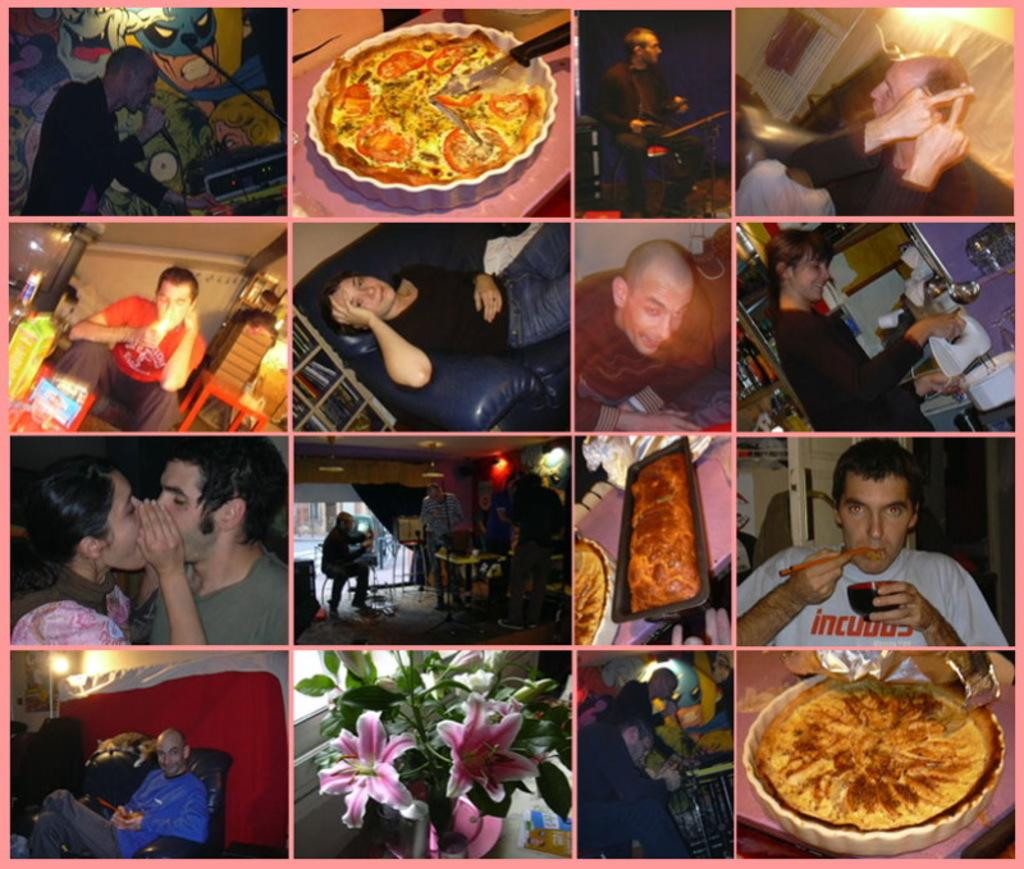What types of images are included in the collage? The collage contains images of persons and food. Can you describe the subjects of the images in the collage? The collage images include persons and various types of food. What type of songs can be heard in the background of the collage? There are no songs or sounds present in the collage, as it is a static image. 